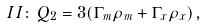<formula> <loc_0><loc_0><loc_500><loc_500>I I \colon \, Q _ { 2 } = 3 ( \Gamma _ { m } \rho _ { m } + \Gamma _ { x } \rho _ { x } ) \, ,</formula> 